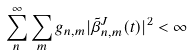<formula> <loc_0><loc_0><loc_500><loc_500>\sum _ { n } ^ { \infty } \sum _ { m } g _ { n , m } | \tilde { \beta } ^ { J } _ { n , m } ( t ) | ^ { 2 } < \infty</formula> 